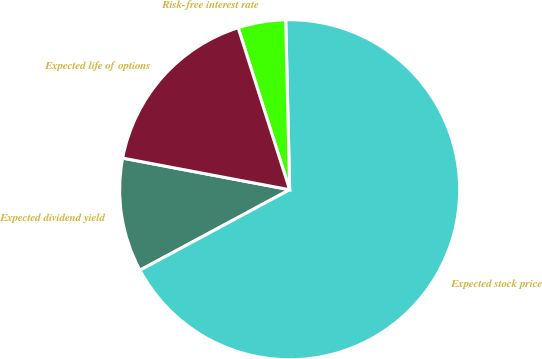Convert chart to OTSL. <chart><loc_0><loc_0><loc_500><loc_500><pie_chart><fcel>Expected dividend yield<fcel>Expected stock price<fcel>Risk-free interest rate<fcel>Expected life of options<nl><fcel>10.83%<fcel>67.52%<fcel>4.53%<fcel>17.12%<nl></chart> 